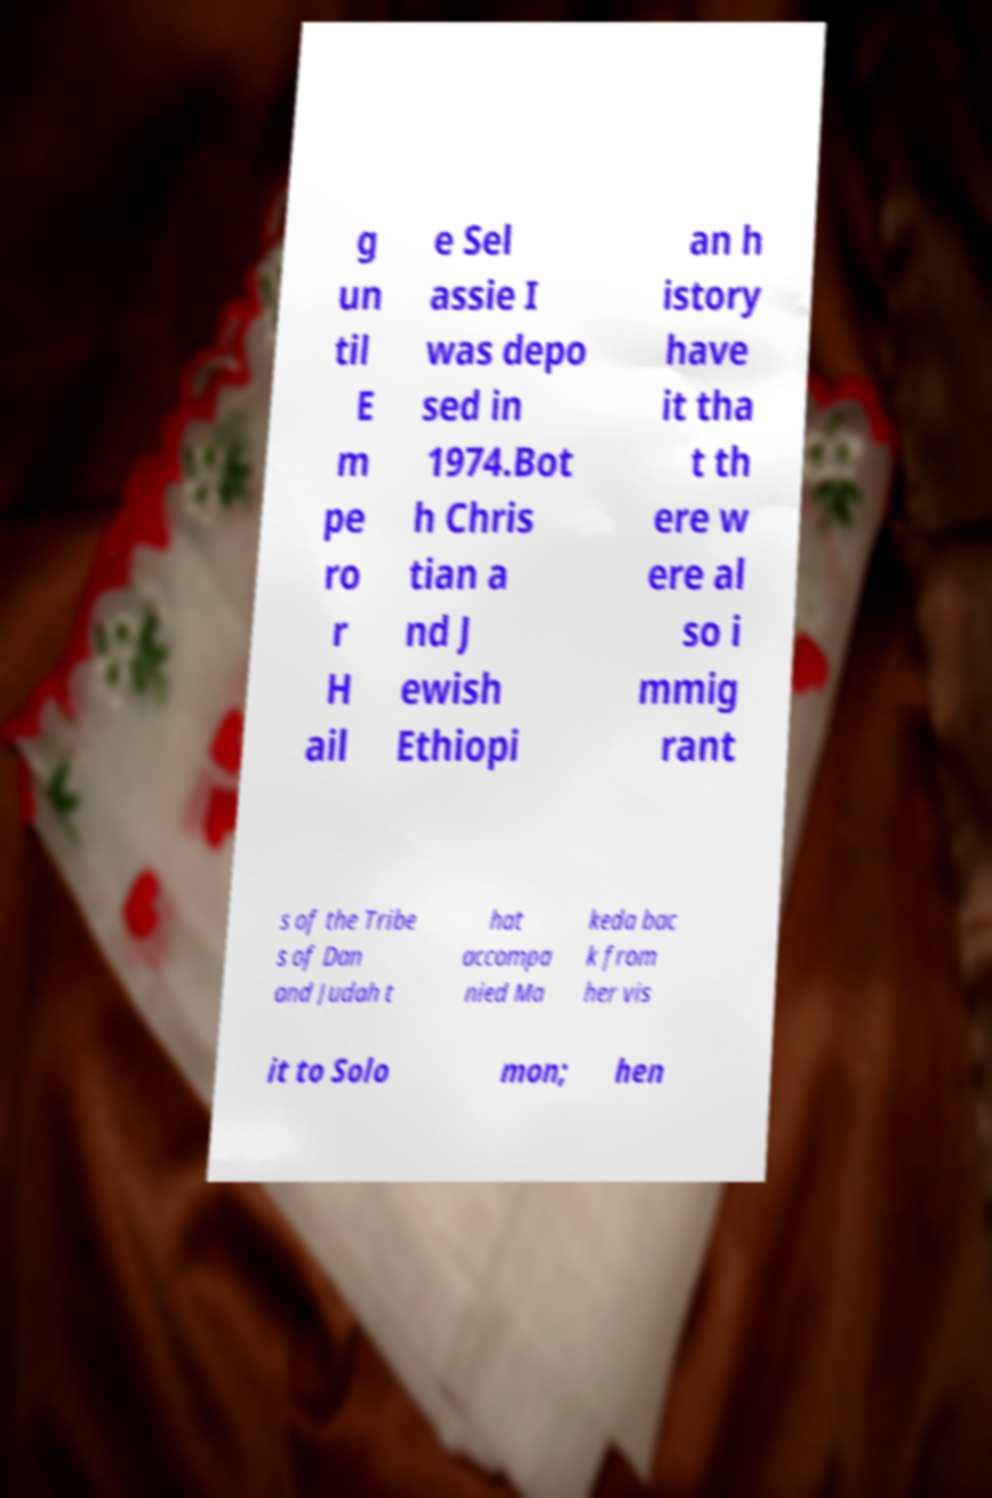Could you extract and type out the text from this image? g un til E m pe ro r H ail e Sel assie I was depo sed in 1974.Bot h Chris tian a nd J ewish Ethiopi an h istory have it tha t th ere w ere al so i mmig rant s of the Tribe s of Dan and Judah t hat accompa nied Ma keda bac k from her vis it to Solo mon; hen 